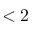Convert formula to latex. <formula><loc_0><loc_0><loc_500><loc_500>< 2</formula> 